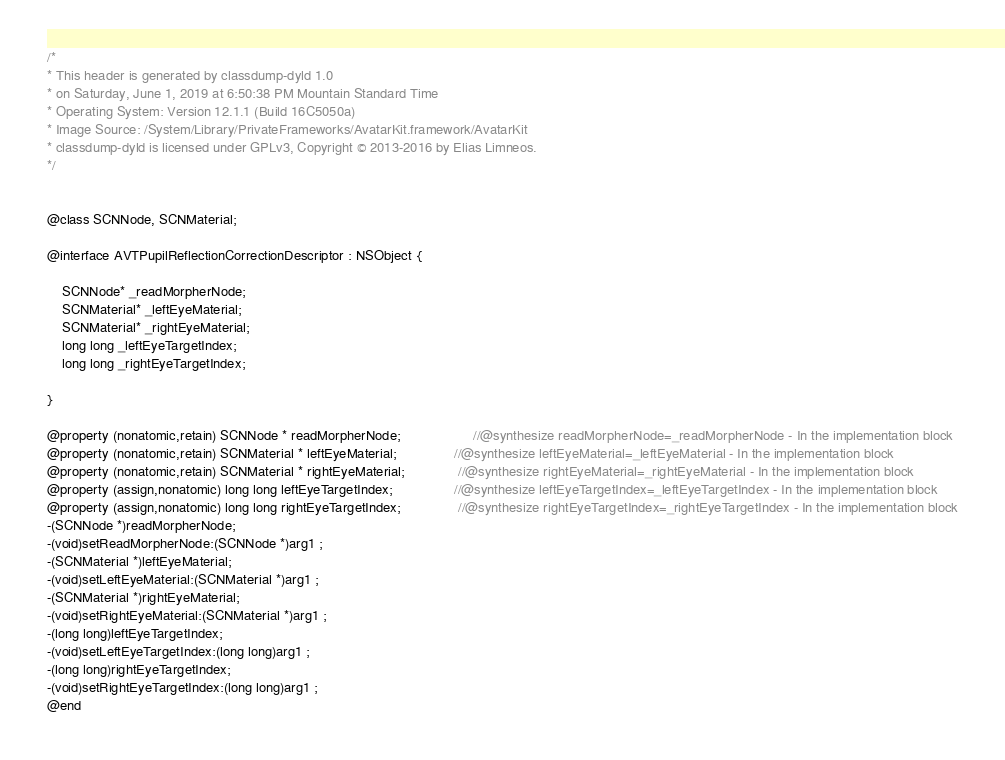<code> <loc_0><loc_0><loc_500><loc_500><_C_>/*
* This header is generated by classdump-dyld 1.0
* on Saturday, June 1, 2019 at 6:50:38 PM Mountain Standard Time
* Operating System: Version 12.1.1 (Build 16C5050a)
* Image Source: /System/Library/PrivateFrameworks/AvatarKit.framework/AvatarKit
* classdump-dyld is licensed under GPLv3, Copyright © 2013-2016 by Elias Limneos.
*/


@class SCNNode, SCNMaterial;

@interface AVTPupilReflectionCorrectionDescriptor : NSObject {

	SCNNode* _readMorpherNode;
	SCNMaterial* _leftEyeMaterial;
	SCNMaterial* _rightEyeMaterial;
	long long _leftEyeTargetIndex;
	long long _rightEyeTargetIndex;

}

@property (nonatomic,retain) SCNNode * readMorpherNode;                   //@synthesize readMorpherNode=_readMorpherNode - In the implementation block
@property (nonatomic,retain) SCNMaterial * leftEyeMaterial;               //@synthesize leftEyeMaterial=_leftEyeMaterial - In the implementation block
@property (nonatomic,retain) SCNMaterial * rightEyeMaterial;              //@synthesize rightEyeMaterial=_rightEyeMaterial - In the implementation block
@property (assign,nonatomic) long long leftEyeTargetIndex;                //@synthesize leftEyeTargetIndex=_leftEyeTargetIndex - In the implementation block
@property (assign,nonatomic) long long rightEyeTargetIndex;               //@synthesize rightEyeTargetIndex=_rightEyeTargetIndex - In the implementation block
-(SCNNode *)readMorpherNode;
-(void)setReadMorpherNode:(SCNNode *)arg1 ;
-(SCNMaterial *)leftEyeMaterial;
-(void)setLeftEyeMaterial:(SCNMaterial *)arg1 ;
-(SCNMaterial *)rightEyeMaterial;
-(void)setRightEyeMaterial:(SCNMaterial *)arg1 ;
-(long long)leftEyeTargetIndex;
-(void)setLeftEyeTargetIndex:(long long)arg1 ;
-(long long)rightEyeTargetIndex;
-(void)setRightEyeTargetIndex:(long long)arg1 ;
@end

</code> 